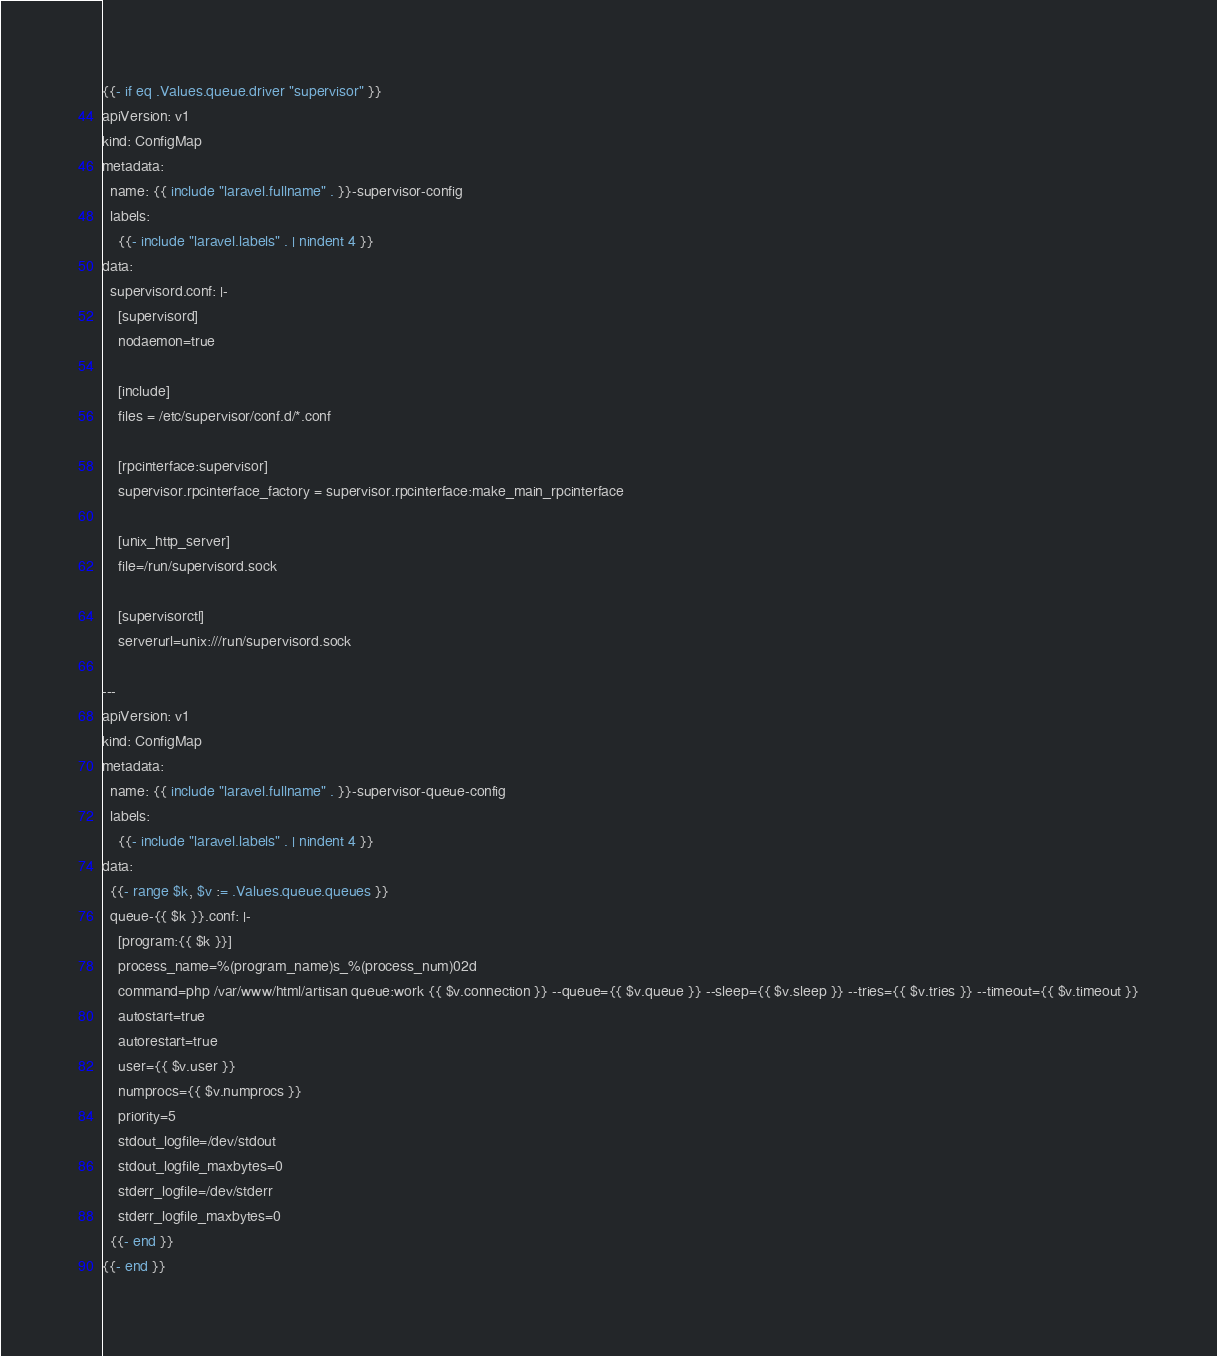Convert code to text. <code><loc_0><loc_0><loc_500><loc_500><_YAML_>{{- if eq .Values.queue.driver "supervisor" }}
apiVersion: v1
kind: ConfigMap
metadata:
  name: {{ include "laravel.fullname" . }}-supervisor-config
  labels:
    {{- include "laravel.labels" . | nindent 4 }}
data:
  supervisord.conf: |-
    [supervisord]
    nodaemon=true

    [include]
    files = /etc/supervisor/conf.d/*.conf

    [rpcinterface:supervisor]
    supervisor.rpcinterface_factory = supervisor.rpcinterface:make_main_rpcinterface

    [unix_http_server]
    file=/run/supervisord.sock

    [supervisorctl]
    serverurl=unix:///run/supervisord.sock

---
apiVersion: v1
kind: ConfigMap
metadata:
  name: {{ include "laravel.fullname" . }}-supervisor-queue-config
  labels:
    {{- include "laravel.labels" . | nindent 4 }}
data:
  {{- range $k, $v := .Values.queue.queues }}
  queue-{{ $k }}.conf: |-
    [program:{{ $k }}]
    process_name=%(program_name)s_%(process_num)02d
    command=php /var/www/html/artisan queue:work {{ $v.connection }} --queue={{ $v.queue }} --sleep={{ $v.sleep }} --tries={{ $v.tries }} --timeout={{ $v.timeout }}
    autostart=true
    autorestart=true
    user={{ $v.user }}
    numprocs={{ $v.numprocs }}
    priority=5
    stdout_logfile=/dev/stdout
    stdout_logfile_maxbytes=0
    stderr_logfile=/dev/stderr
    stderr_logfile_maxbytes=0
  {{- end }}
{{- end }}</code> 